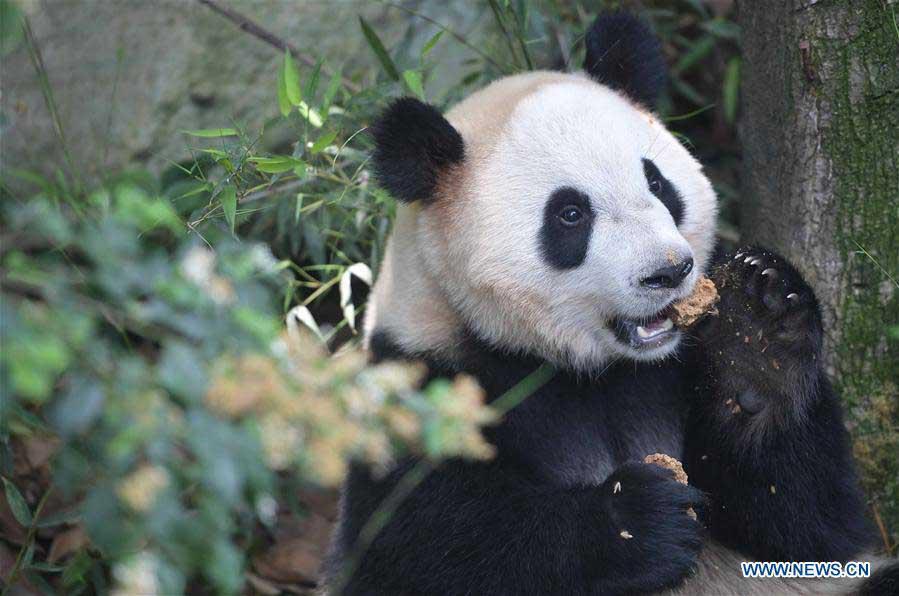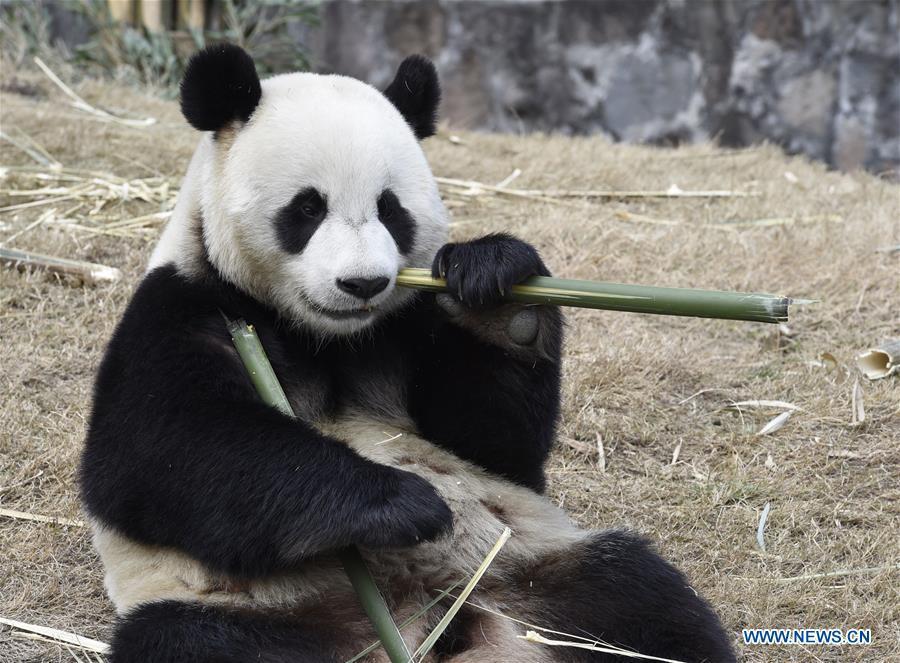The first image is the image on the left, the second image is the image on the right. Analyze the images presented: Is the assertion "Both images in the pair have two pandas." valid? Answer yes or no. No. The first image is the image on the left, the second image is the image on the right. For the images displayed, is the sentence "One image shows pandas sitting side by side, each with a paw raised to its mouth, and the other image shows two pandas who are looking toward one another." factually correct? Answer yes or no. No. 